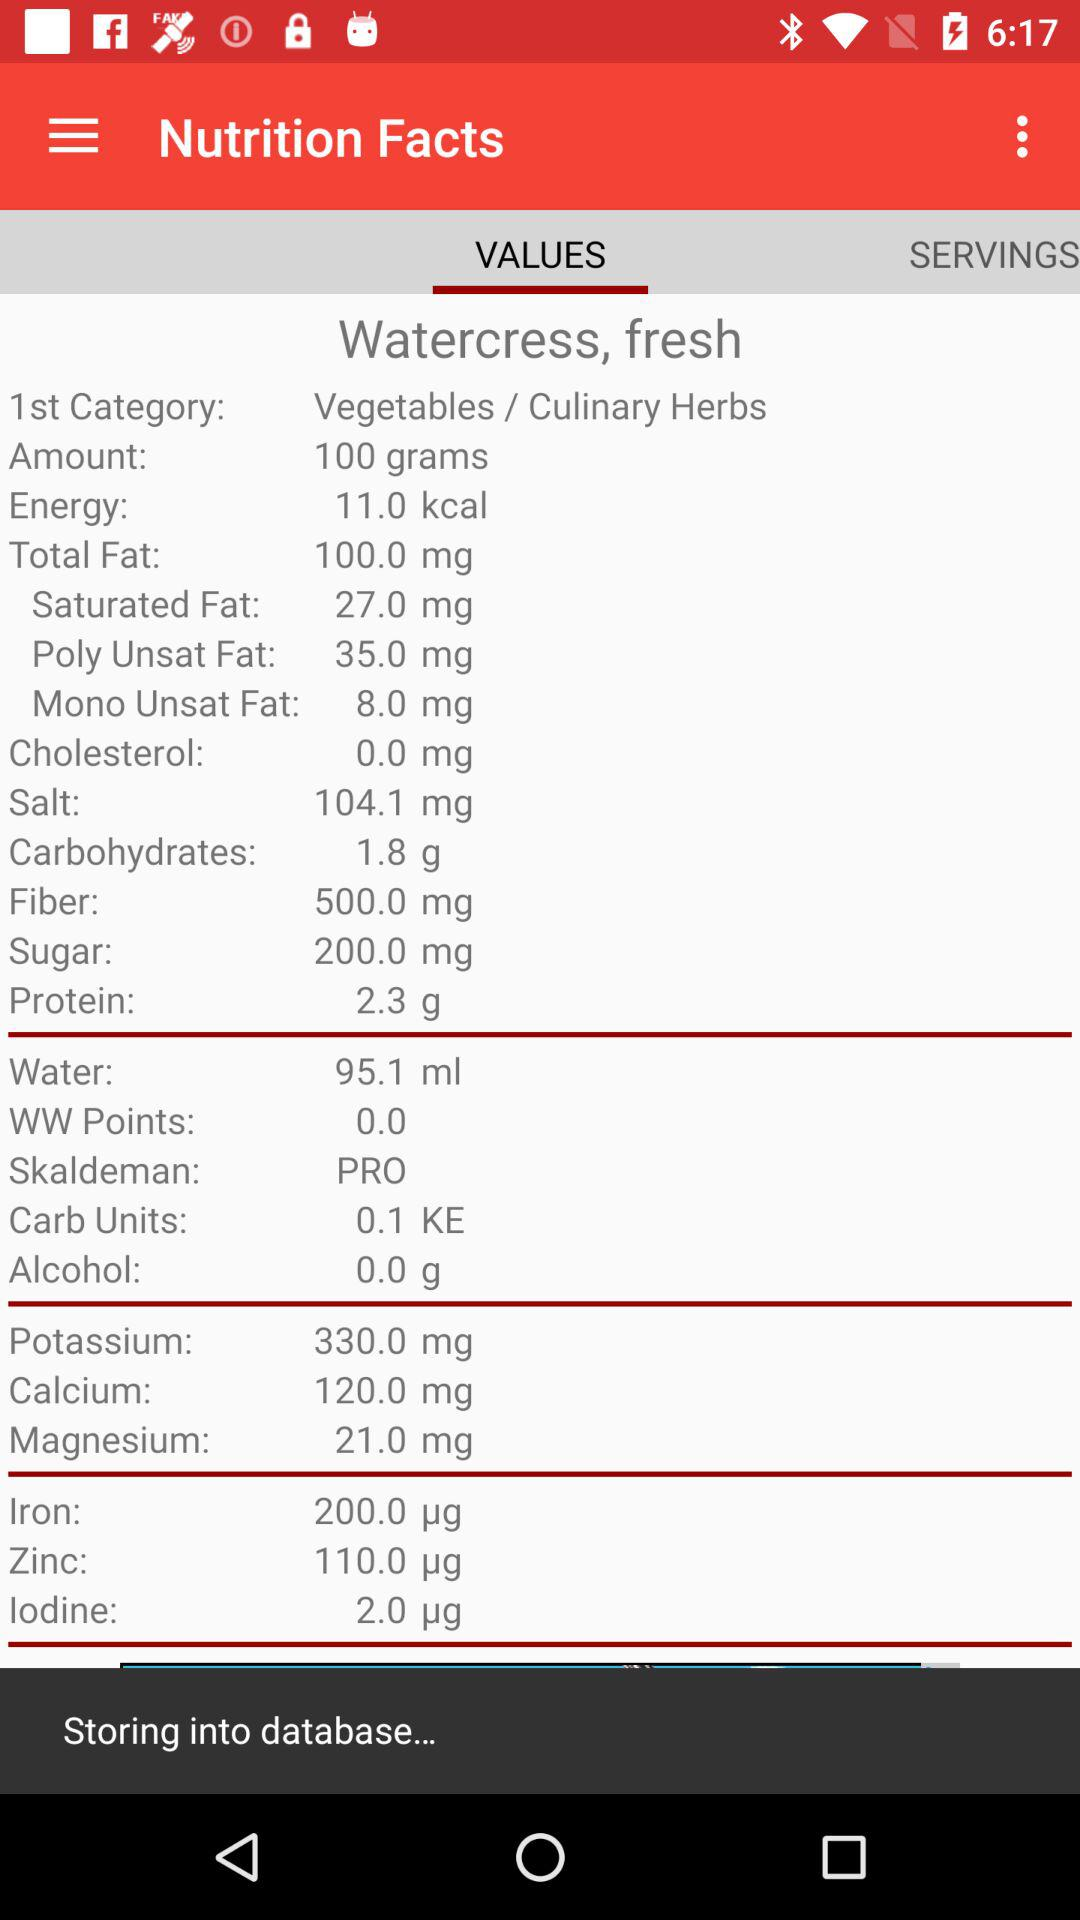Which option is selected in the "Nutrition Facts"? The option that is selected in the "Nutrition Facts" is "VALUES". 